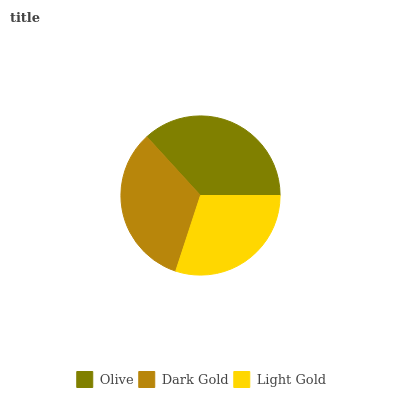Is Light Gold the minimum?
Answer yes or no. Yes. Is Olive the maximum?
Answer yes or no. Yes. Is Dark Gold the minimum?
Answer yes or no. No. Is Dark Gold the maximum?
Answer yes or no. No. Is Olive greater than Dark Gold?
Answer yes or no. Yes. Is Dark Gold less than Olive?
Answer yes or no. Yes. Is Dark Gold greater than Olive?
Answer yes or no. No. Is Olive less than Dark Gold?
Answer yes or no. No. Is Dark Gold the high median?
Answer yes or no. Yes. Is Dark Gold the low median?
Answer yes or no. Yes. Is Light Gold the high median?
Answer yes or no. No. Is Light Gold the low median?
Answer yes or no. No. 